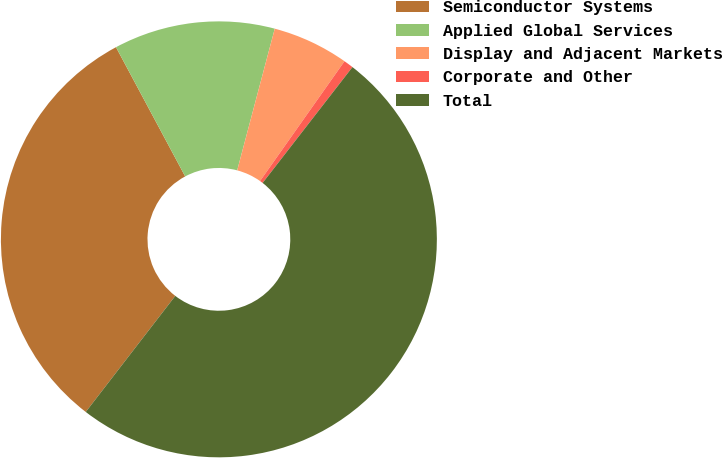Convert chart. <chart><loc_0><loc_0><loc_500><loc_500><pie_chart><fcel>Semiconductor Systems<fcel>Applied Global Services<fcel>Display and Adjacent Markets<fcel>Corporate and Other<fcel>Total<nl><fcel>31.72%<fcel>11.95%<fcel>5.65%<fcel>0.72%<fcel>49.96%<nl></chart> 